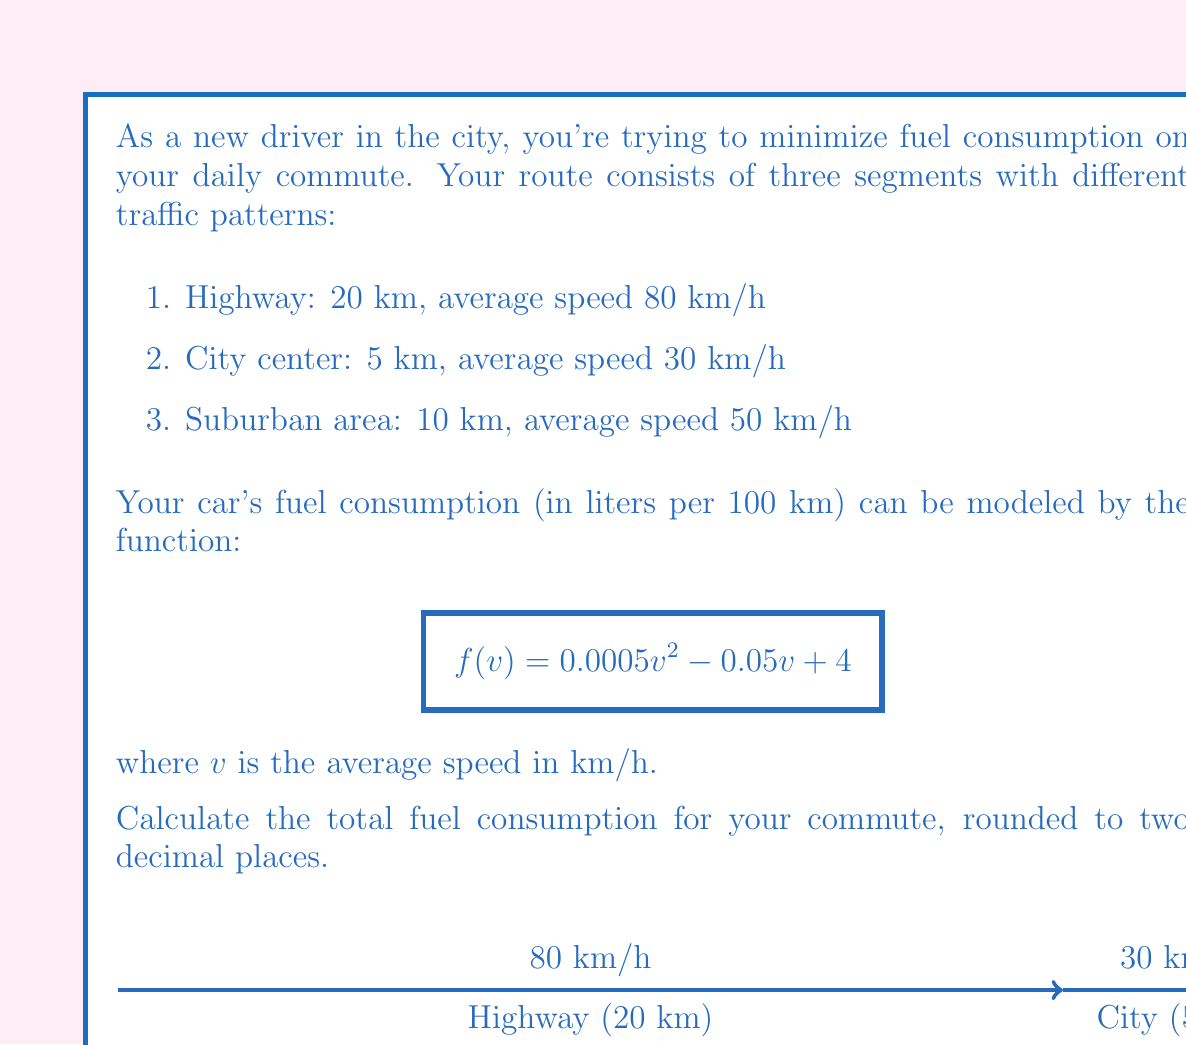Solve this math problem. Let's approach this problem step-by-step:

1) First, we need to calculate the fuel consumption for each segment of the route.

2) For the highway segment:
   - Distance = 20 km
   - Speed = 80 km/h
   - Fuel consumption = $f(80) = 0.0005(80)^2 - 0.05(80) + 4 = 3.2$ L/100km
   - Fuel used = $3.2 \times \frac{20}{100} = 0.64$ L

3) For the city center segment:
   - Distance = 5 km
   - Speed = 30 km/h
   - Fuel consumption = $f(30) = 0.0005(30)^2 - 0.05(30) + 4 = 3.45$ L/100km
   - Fuel used = $3.45 \times \frac{5}{100} = 0.1725$ L

4) For the suburban area segment:
   - Distance = 10 km
   - Speed = 50 km/h
   - Fuel consumption = $f(50) = 0.0005(50)^2 - 0.05(50) + 4 = 3.25$ L/100km
   - Fuel used = $3.25 \times \frac{10}{100} = 0.325$ L

5) Total fuel consumption is the sum of all segments:
   $0.64 + 0.1725 + 0.325 = 1.1375$ L

6) Rounding to two decimal places: 1.14 L

Therefore, the total fuel consumption for the commute is 1.14 liters.
Answer: 1.14 L 